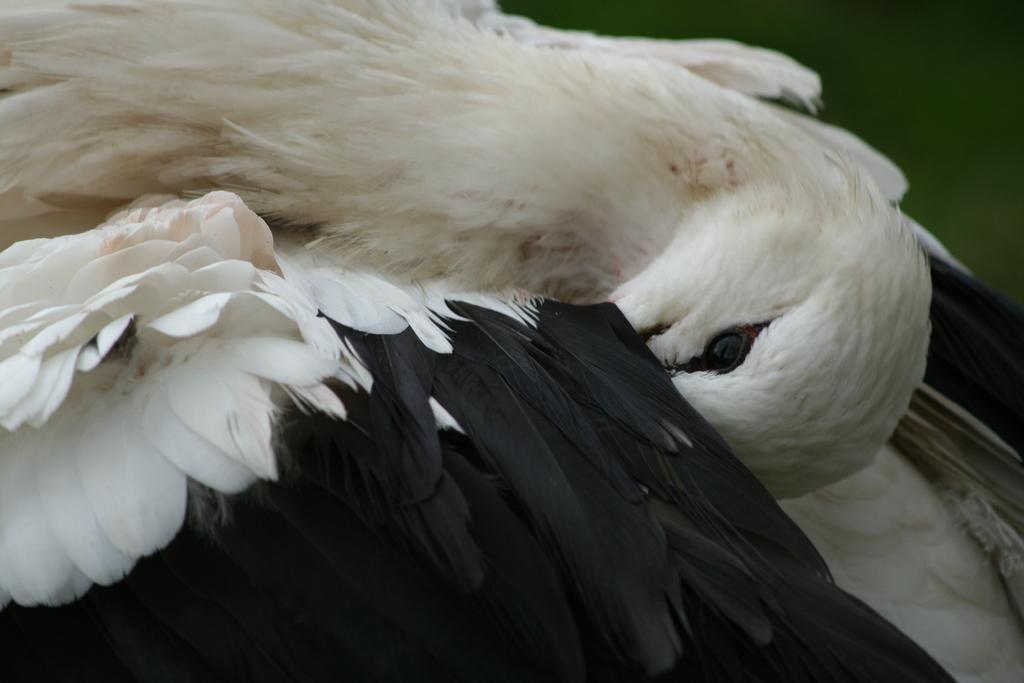Describe this image in one or two sentences. In this image we can see a bird. 